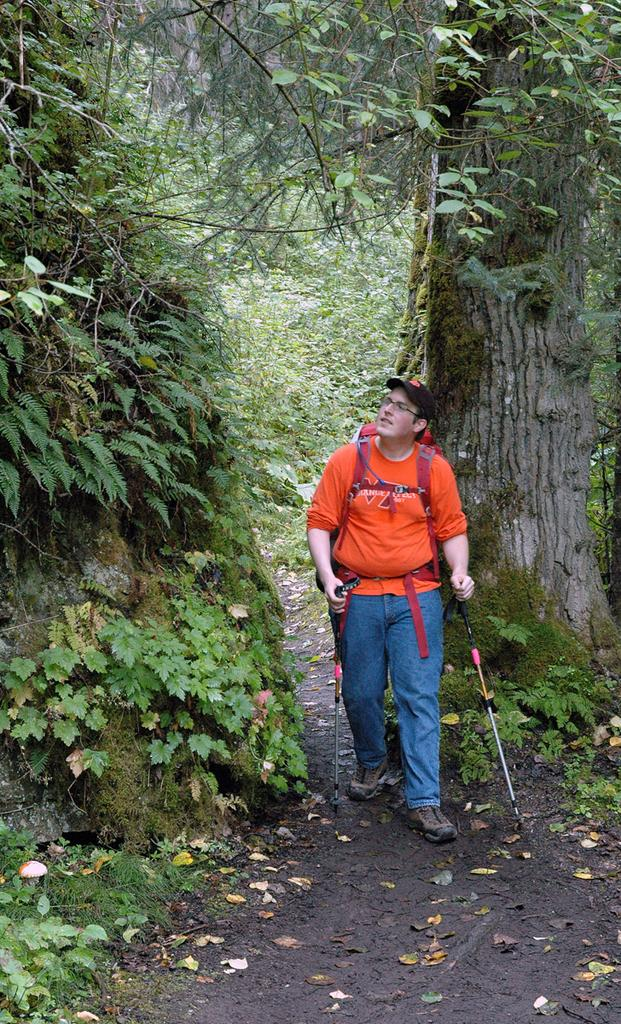Who is the main subject in the image? There is a man in the center of the image. What is the man holding in his hands? The man is holding walking sticks in his hands. What can be seen on both sides of the image? There is greenery on both sides of the image. Where is the woman washing the cow in the image? There is no woman or cow present in the image; it only features a man holding walking sticks. 